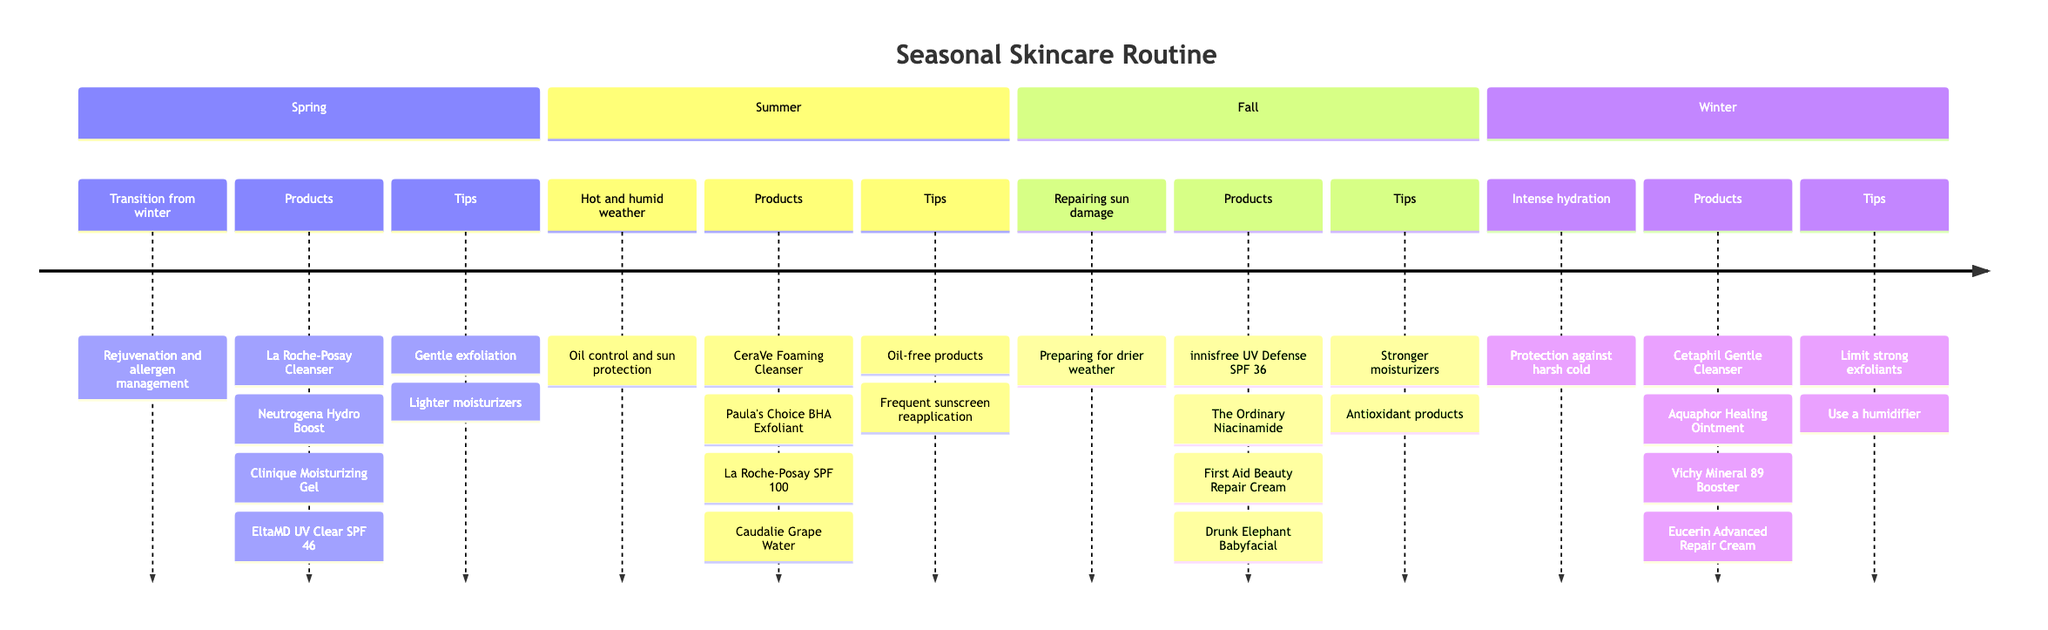What is the primary focus of the Spring skincare routine? The diagram indicates that Spring's focus is on rejuvenation and allergen management, transitioning from winter to deal with increased pollen and allergens.
Answer: Rejuvenation and allergen management How many products are listed for the Summer season? Counting the products listed under the Summer section shows there are four products: CeraVe Foaming Cleanser, Paula's Choice BHA Exfoliant, La Roche-Posay SPF 100, and Caudalie Grape Water.
Answer: Four What is a key tip for Winter skincare? The Winter section emphasizes limiting the use of strong exfoliants to avoid over-drying the skin. This information is explicitly mentioned as a recommendation for Winter.
Answer: Limit strong exfoliants Which product is recommended in Fall to help reduce blemishes? The diagram notes that The Ordinary Niacinamide 10% + Zinc 1% is recommended in Fall specifically for reducing the appearance of blemishes and congestion.
Answer: The Ordinary Niacinamide What seasonal transition does the routine emphasize in Spring? The routine indicates that Spring is a transition from winter to spring, focusing on rejuvenation and dealing with increased pollen and allergens as the climate shifts.
Answer: Transition from winter to spring What is the purpose of the La Roche-Posay Anthelios Melt-in Milk Sunscreen in Summer? According to the diagram, this sunscreen is intended to provide high-level sun protection, which is critical during outdoor activities in the hot and humid summer weather.
Answer: High-level sun protection How does the goal of skincare change from Summer to Fall? The diagram highlights that while Summer focuses on oil control and sun protection due to heat and humidity, Fall transitions to repairing sun damage and preparing for drier weather as temperatures drop.
Answer: Repairing sun damage and preparing for drier weather What product is used for cleansing in Winter? The Winter section lists Cetaphil Gentle Skin Cleanser as the product used for cleansing without stripping essential moisture, making it suitable for the colder season.
Answer: Cetaphil Gentle Skin Cleanser 